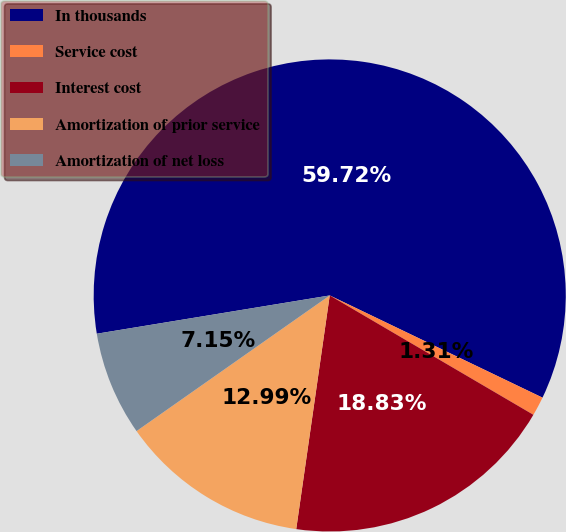Convert chart to OTSL. <chart><loc_0><loc_0><loc_500><loc_500><pie_chart><fcel>In thousands<fcel>Service cost<fcel>Interest cost<fcel>Amortization of prior service<fcel>Amortization of net loss<nl><fcel>59.72%<fcel>1.31%<fcel>18.83%<fcel>12.99%<fcel>7.15%<nl></chart> 